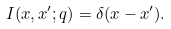Convert formula to latex. <formula><loc_0><loc_0><loc_500><loc_500>I ( x , x ^ { \prime } ; q ) = \delta ( x - x ^ { \prime } ) .</formula> 